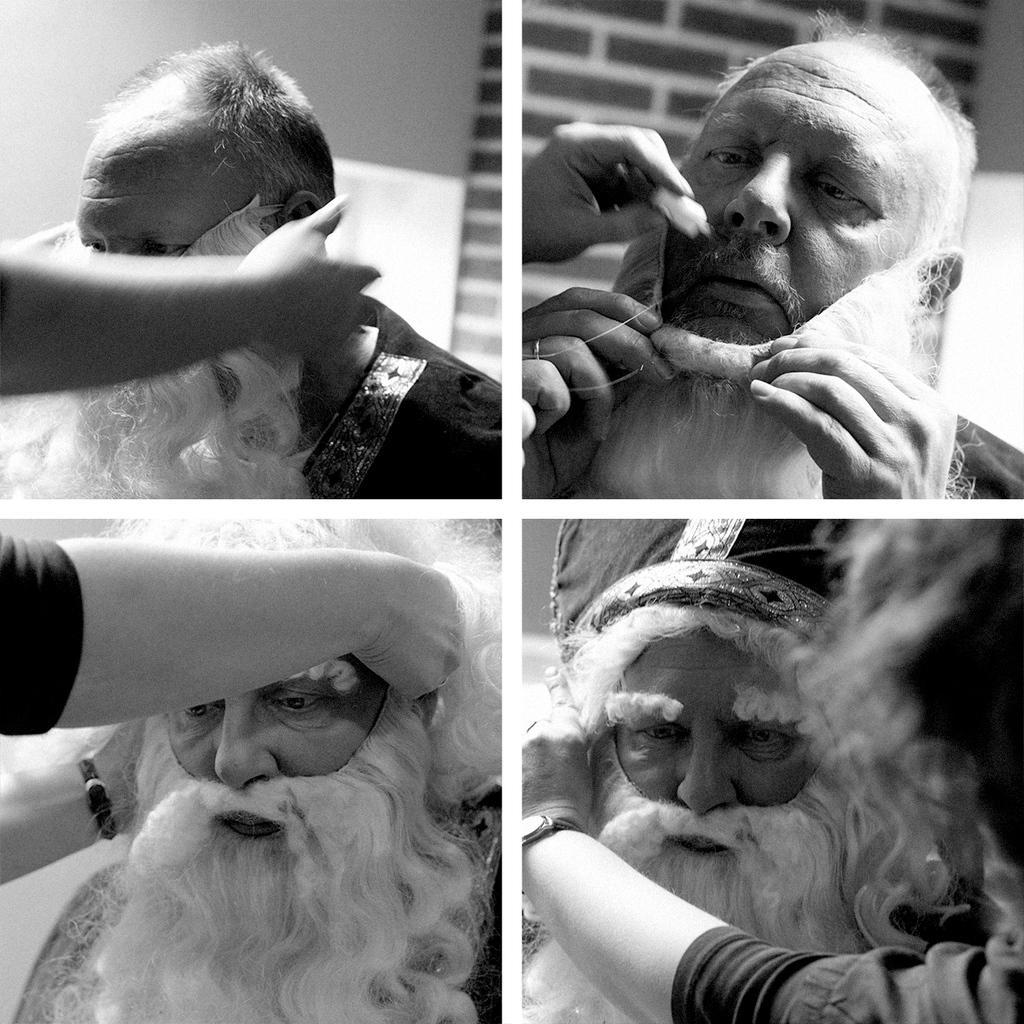How would you summarize this image in a sentence or two? This is black and white collage image, in this image there is a man wearing getup. 